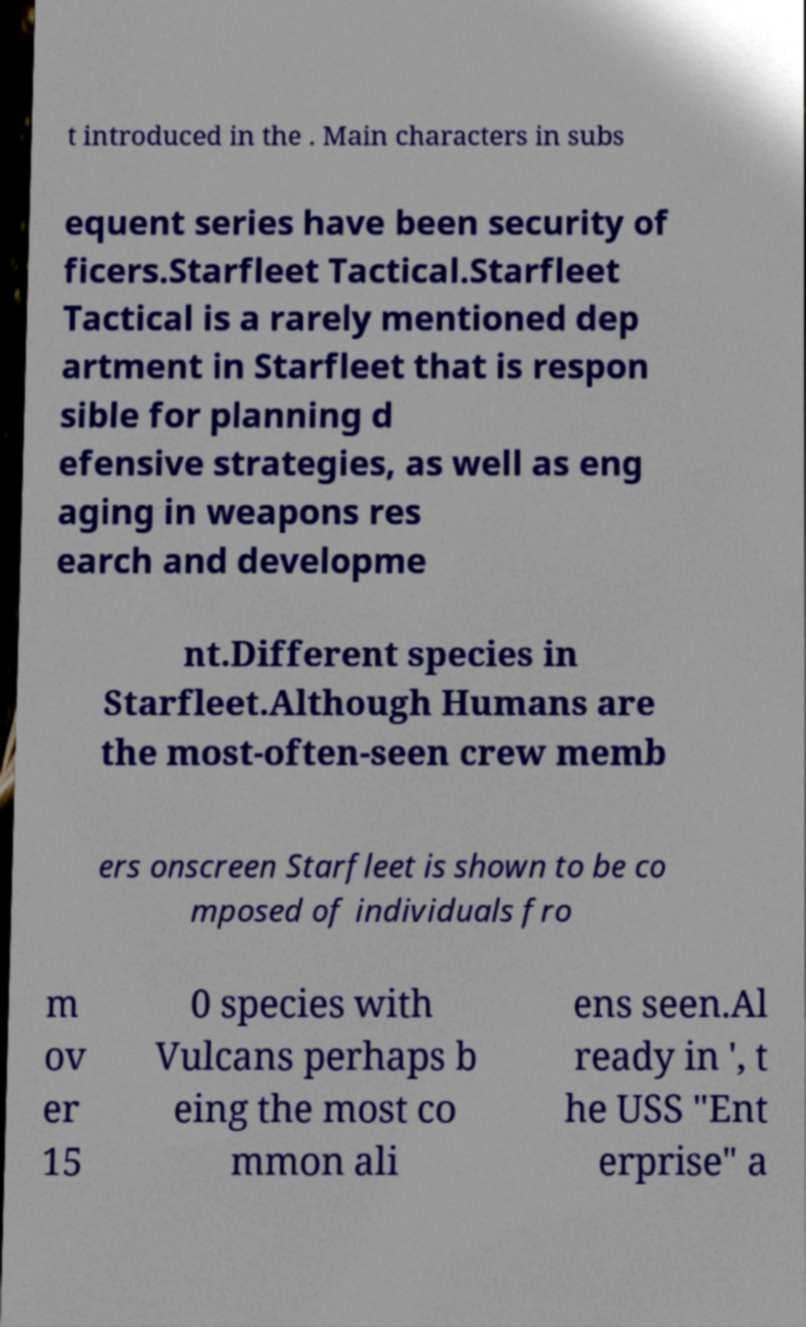For documentation purposes, I need the text within this image transcribed. Could you provide that? t introduced in the . Main characters in subs equent series have been security of ficers.Starfleet Tactical.Starfleet Tactical is a rarely mentioned dep artment in Starfleet that is respon sible for planning d efensive strategies, as well as eng aging in weapons res earch and developme nt.Different species in Starfleet.Although Humans are the most-often-seen crew memb ers onscreen Starfleet is shown to be co mposed of individuals fro m ov er 15 0 species with Vulcans perhaps b eing the most co mmon ali ens seen.Al ready in ', t he USS "Ent erprise" a 